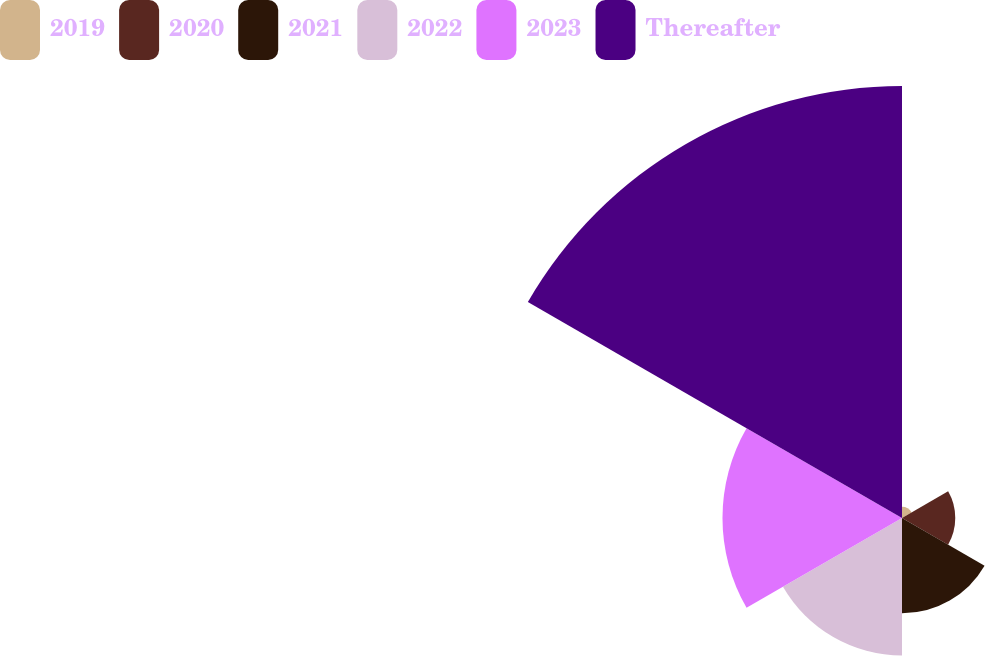<chart> <loc_0><loc_0><loc_500><loc_500><pie_chart><fcel>2019<fcel>2020<fcel>2021<fcel>2022<fcel>2023<fcel>Thereafter<nl><fcel>1.23%<fcel>5.86%<fcel>10.49%<fcel>15.12%<fcel>19.75%<fcel>47.53%<nl></chart> 